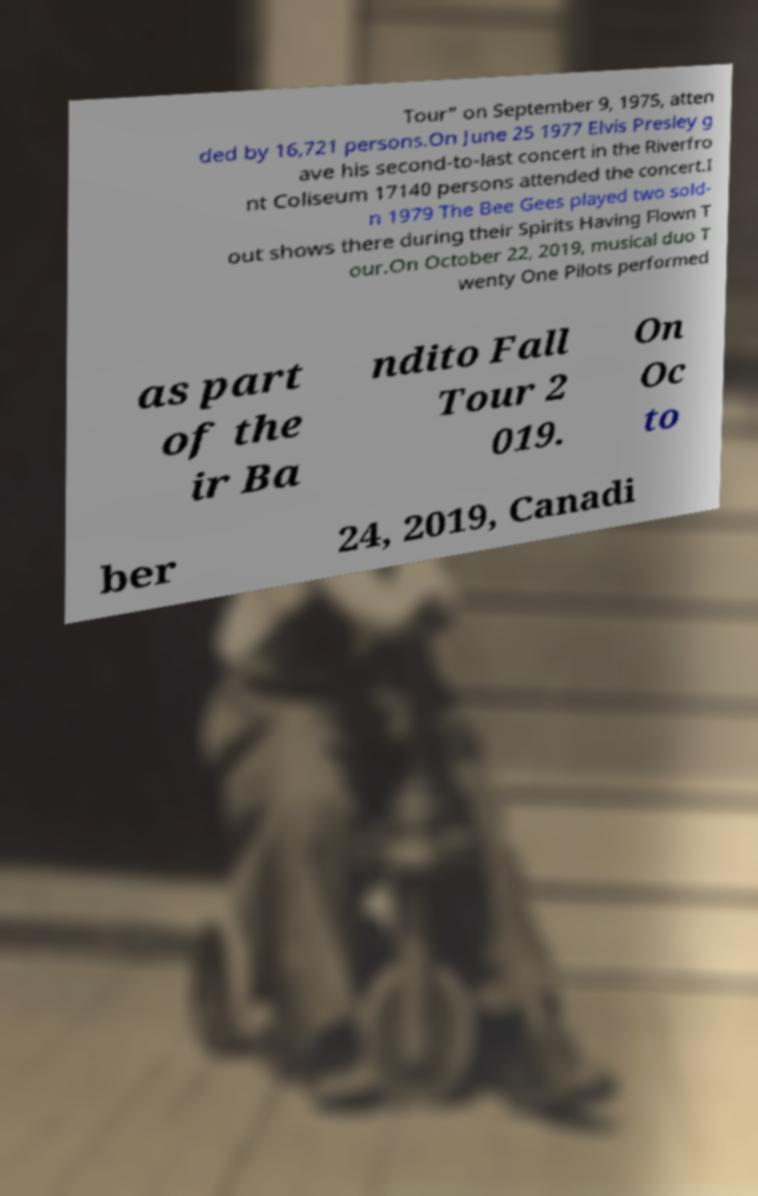For documentation purposes, I need the text within this image transcribed. Could you provide that? Tour" on September 9, 1975, atten ded by 16,721 persons.On June 25 1977 Elvis Presley g ave his second-to-last concert in the Riverfro nt Coliseum 17140 persons attended the concert.I n 1979 The Bee Gees played two sold- out shows there during their Spirits Having Flown T our.On October 22, 2019, musical duo T wenty One Pilots performed as part of the ir Ba ndito Fall Tour 2 019. On Oc to ber 24, 2019, Canadi 